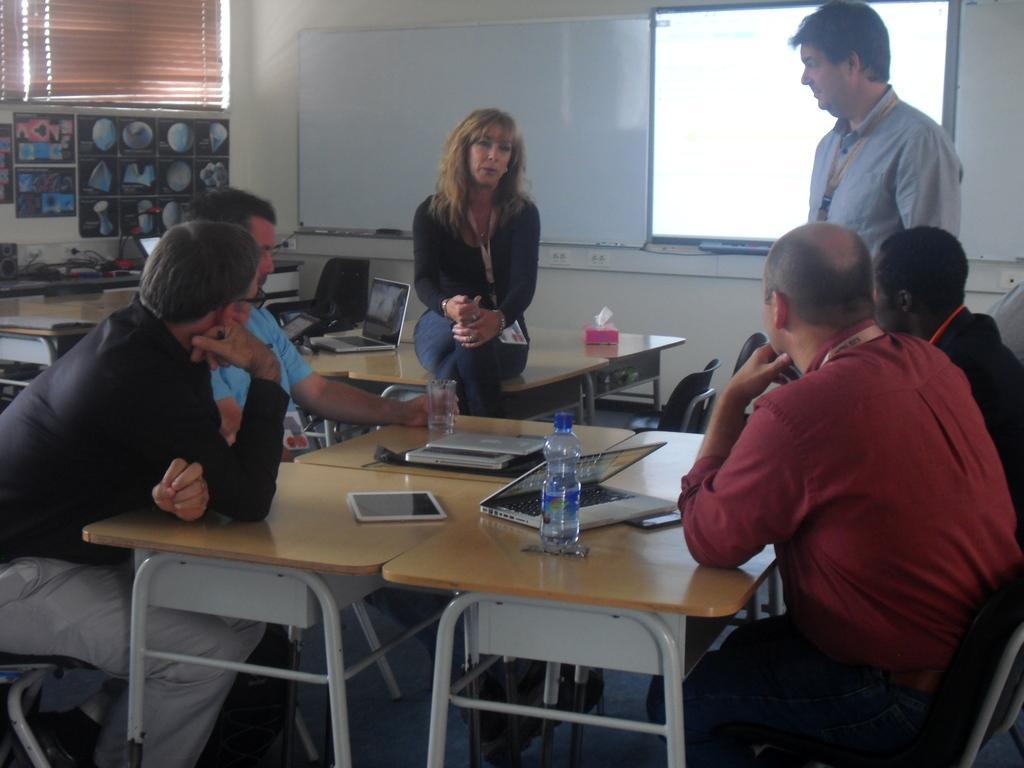Can you describe this image briefly? There are some persons sitting and standing in the room. There are many tables. On the table there are laptops, tabs, bottles, and glasses and tissues. In the background there is a wall, curtain, board and a screen 